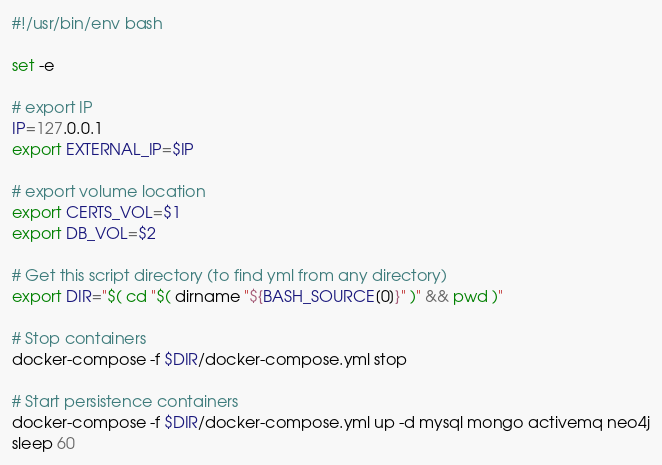Convert code to text. <code><loc_0><loc_0><loc_500><loc_500><_Bash_>#!/usr/bin/env bash

set -e

# export IP
IP=127.0.0.1
export EXTERNAL_IP=$IP

# export volume location
export CERTS_VOL=$1
export DB_VOL=$2

# Get this script directory (to find yml from any directory)
export DIR="$( cd "$( dirname "${BASH_SOURCE[0]}" )" && pwd )"

# Stop containers
docker-compose -f $DIR/docker-compose.yml stop

# Start persistence containers
docker-compose -f $DIR/docker-compose.yml up -d mysql mongo activemq neo4j
sleep 60
</code> 